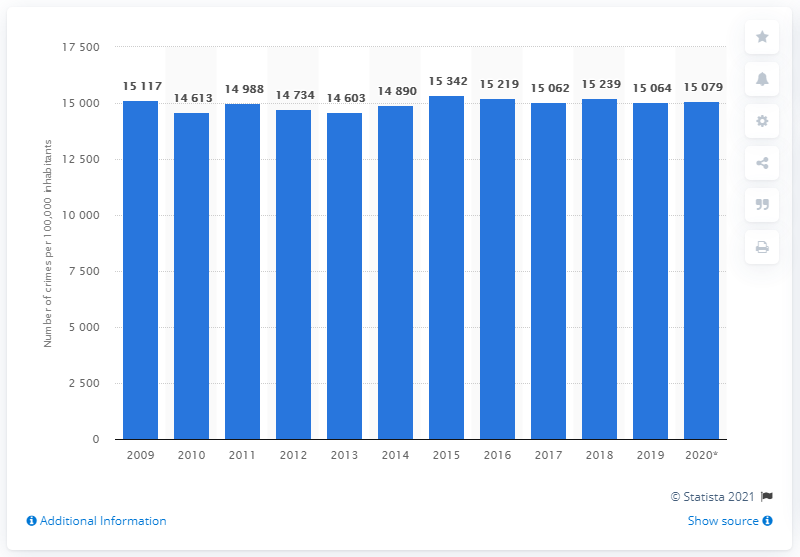What year had the lowest crime rate according to this graph, and could you provide a possible explanation for this trend? The graph indicates that the year 2014 had the lowest reported crime rate within the displayed timeframe, with 14,603 crimes per 100,000 inhabitants. Several factors could contribute to this trend, such as effective policing strategies, economic conditions, social welfare programs, and legislation changes. Without additional context or data, it's challenging to pinpoint the exact reason for this decrease. 